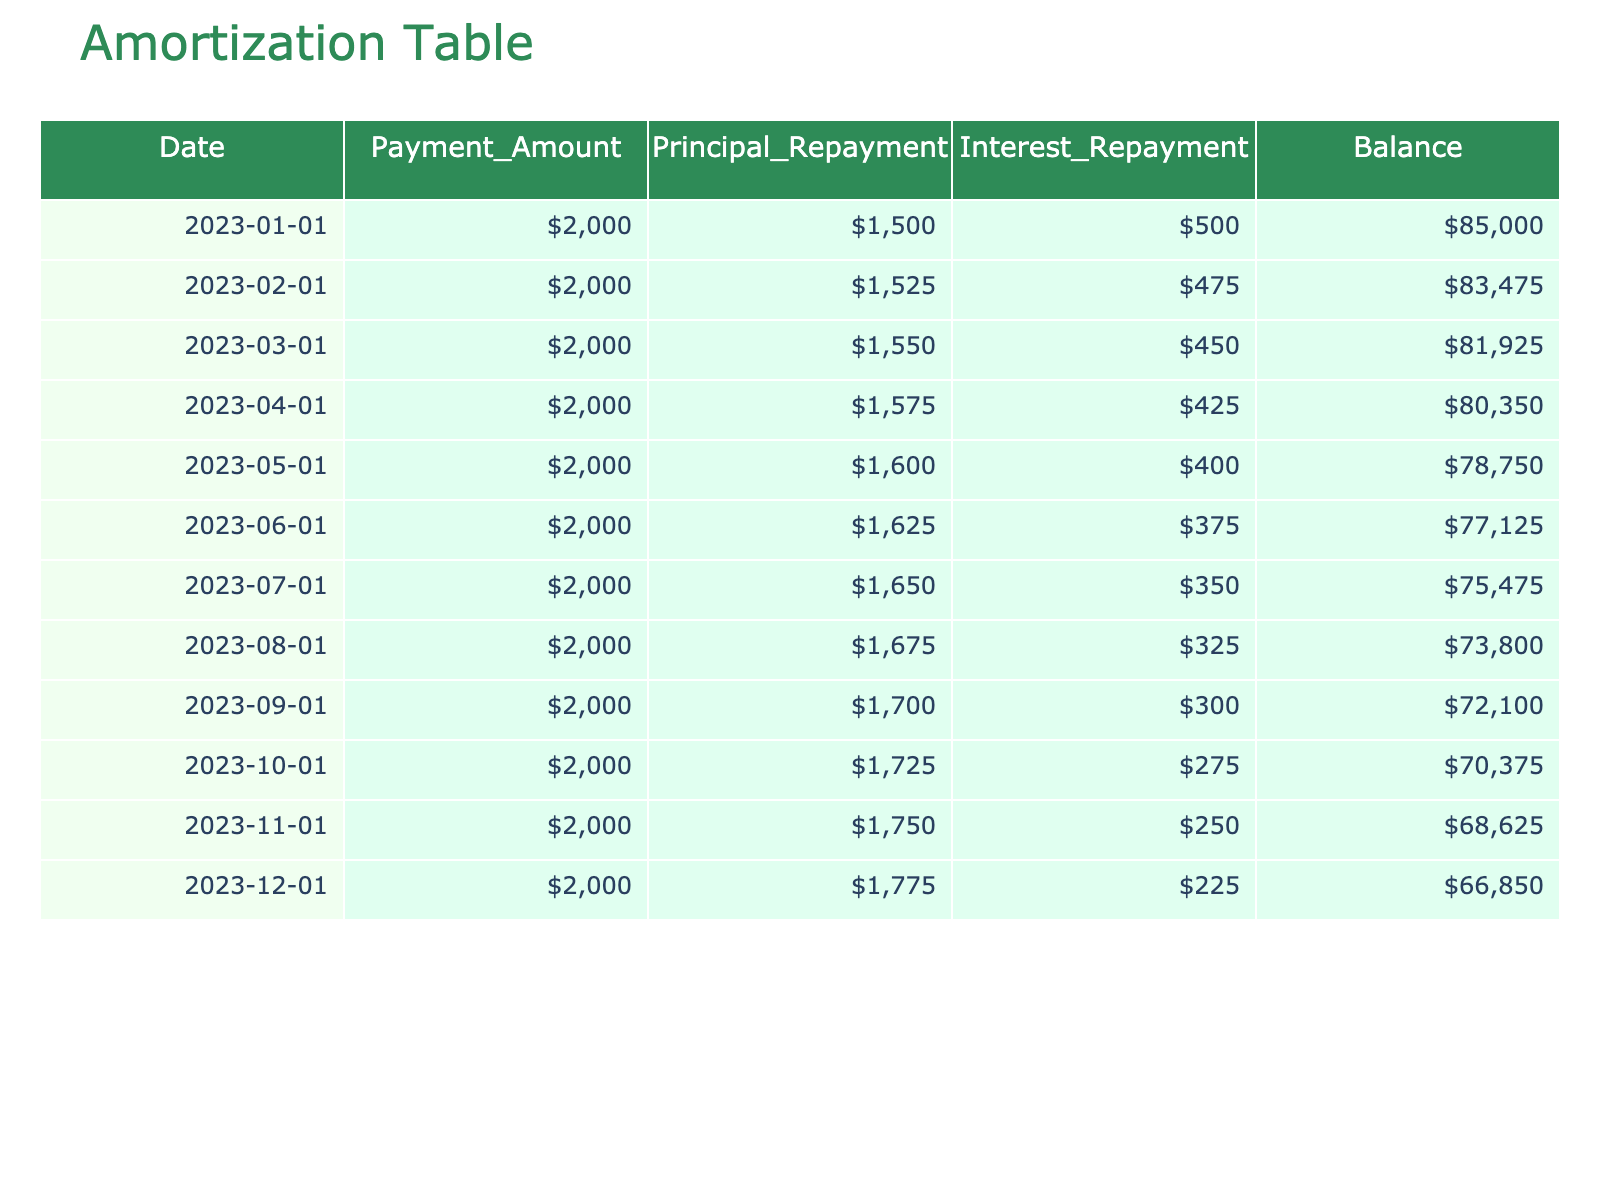What was the principal repayment amount in February 2023? According to the table, the principal repayment for February 2023 is shown directly under the 'Principal_Repayment' column for that date. The amount is $1,525.
Answer: 1,525 What is the total interest repayment over the 12 months? To find the total interest repayment, I need to sum the 'Interest_Repayment' values for all months. The individual amounts are $500, $475, $450, $425, $400, $375, $350, $325, $300, $275, $250, and $225. Adding these up gives $500 + 475 + 450 + 425 + 400 + 375 + 350 + 325 + 300 + 275 + 250 + 225 = $4,825.
Answer: 4,825 Did the balance ever drop below $70,000 during this period? By observing the 'Balance' column, the lowest value is $68,650 in December 2023. Since this value is below $70,000, the answer is yes.
Answer: Yes What was the largest principal repayment amount made in a single month? To find the largest principal repayment, I will compare each month's 'Principal_Repayment' amounts listed. The amounts are $1,500, $1,525, $1,550, $1,575, $1,600, $1,625, $1,650, $1,675, $1,700, $1,725, $1,750, and $1,775. The highest amount is $1,775 in December 2023.
Answer: 1,775 What is the average monthly payment amount? The average monthly payment amount can be calculated by summing all 'Payment_Amount' values and dividing by 12 months. Each month has a consistent payment of $2,000, thus the total is $2,000 * 12 = $24,000. Dividing by 12 gives an average of $2,000.
Answer: 2,000 What is the balance reduction from January to December 2023? The balance in January 2023 is $85,000, and in December 2023 it is $66,850. To find the reduction, I subtract the December balance from the January balance: $85,000 - $66,850 = $18,150.
Answer: 18,150 Is the total amount of principal repaid greater than the total interest repaid by the end of the year? The total principal repaid is the sum of 'Principal_Repayment', which is $1,500 + 1,525 + ... + 1,775 = $20,975, while the total interest is $4,825. Since $20,975 is much greater than $4,825, the answer is yes.
Answer: Yes How much was the balance at the end of the first quarter (March 2023)? For the balance at the end of March, look at the ‘Balance’ column for March 2023, which shows $81,925.
Answer: 81,925 What was the change in payment amounts from January to November? The payment amount remains consistently at $2,000 from January to November, so there is no change. The difference is $2,000 - $2,000 = $0.
Answer: 0 